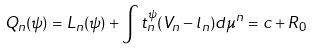<formula> <loc_0><loc_0><loc_500><loc_500>Q _ { n } ( \psi ) = L _ { n } ( \psi ) + \int t _ { n } ^ { \psi } ( V _ { n } - l _ { n } ) d \mu ^ { n } = c + R _ { 0 }</formula> 